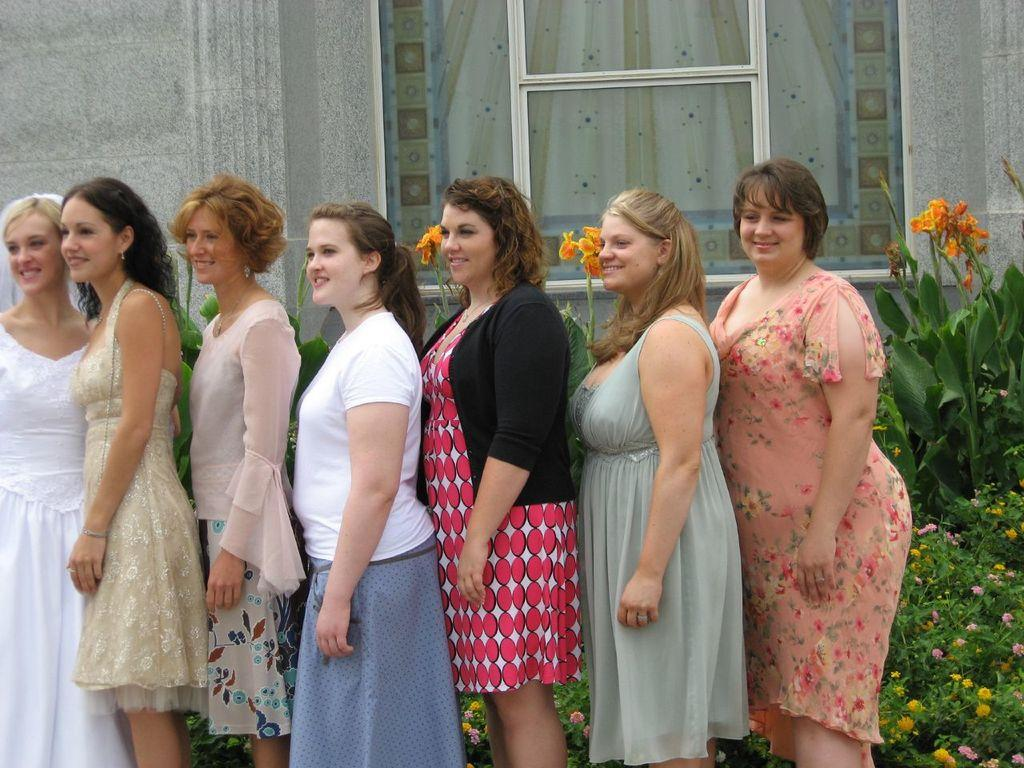How many people are in the image? There is a group of people in the image. What are the people doing in the image? The people are standing and smiling. What can be seen in the background of the image? There is a building, plants and flowers, and a board behind a window in the background of the image. What type of metal is used to make the egg in the image? There is no egg present in the image, and therefore no metal can be associated with it. What decision is being made by the people in the image? The image does not provide any information about a decision being made by the people; they are simply standing and smiling. 